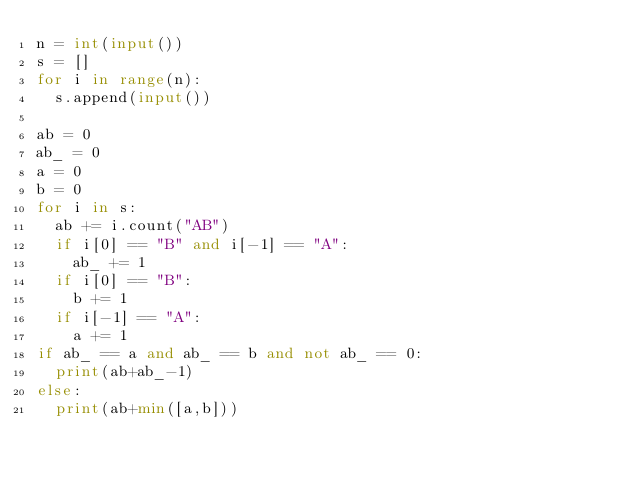Convert code to text. <code><loc_0><loc_0><loc_500><loc_500><_Python_>n = int(input())
s = []
for i in range(n):
  s.append(input())
     
ab = 0
ab_ = 0
a = 0
b = 0
for i in s:
  ab += i.count("AB")
  if i[0] == "B" and i[-1] == "A":
    ab_ += 1
  if i[0] == "B":
    b += 1
  if i[-1] == "A":
    a += 1
if ab_ == a and ab_ == b and not ab_ == 0:
  print(ab+ab_-1)
else:
  print(ab+min([a,b]))</code> 